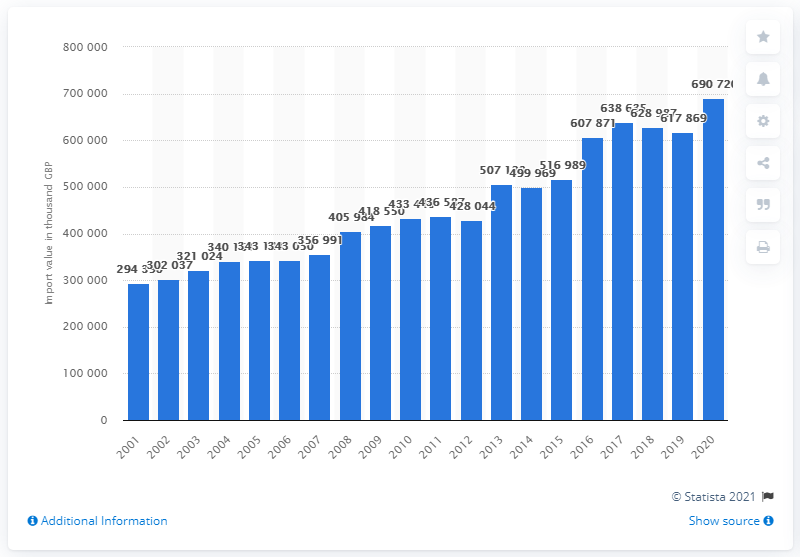Outline some significant characteristics in this image. In 2001, fresh or dried citrus fruit was first imported to the UK. 